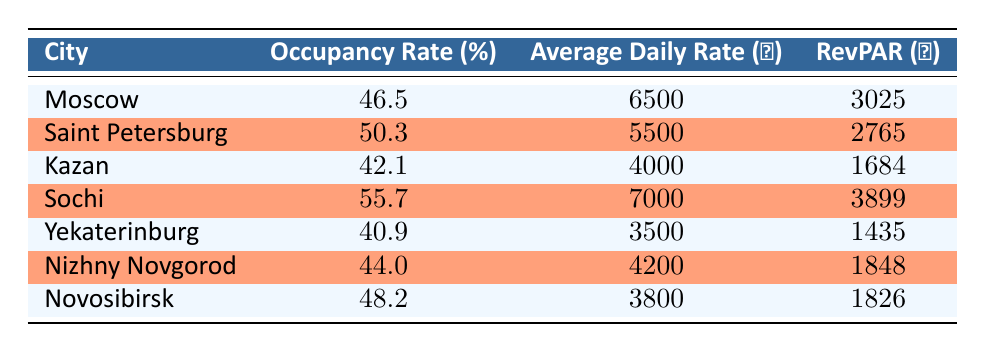What is the highest hotel occupancy rate among the listed cities? The table shows the occupancy rates for each city. Upon reviewing the numbers, Sochi has the highest rate at 55.7%.
Answer: 55.7 How does the average daily rate in Saint Petersburg compare to that in Moscow? Looking at the average daily rates, Saint Petersburg has an average daily rate of 5500, while Moscow has 6500. Comparing these, Moscow's rate is higher by 1000.
Answer: 1000 Is the revenue per available room (RevPAR) in Kazan greater than in Yekaterinburg? The values for RevPAR show Kazan at 1684 and Yekaterinburg at 1435. Since 1684 is greater than 1435, the statement is true.
Answer: Yes What is the average hotel occupancy rate for all the cities listed? To find the average occupancy rate, we sum all the rates (46.5 + 50.3 + 42.1 + 55.7 + 40.9 + 44.0 + 48.2) = 327.7. Then, we divide by the number of cities, which is 7: 327.7 / 7 = 46.7.
Answer: 46.7 Is the average daily rate for Novosibirsk less than the occupancy rate for Kazan? The average daily rate for Novosibirsk is 3800, and the occupancy rate for Kazan is 42.1%. Since the average daily rate is not less than the occupancy rate, the statement is false.
Answer: No Which city has the lowest revenue per available room (RevPAR)? By comparing the RevPAR values, we find that Yekaterinburg has the lowest value at 1435.
Answer: Yekaterinburg What is the total revenue generated per available room when combining the RevPAR of Moscow and Nizhny Novgorod? The RevPAR for Moscow is 3025 and for Nizhny Novgorod it is 1848. Adding these two values gives us a total of 3025 + 1848 = 4873.
Answer: 4873 Which city has both a higher occupancy rate and a higher average daily rate compared to Yekaterinburg? Yekaterinburg's occupancy rate is 40.9%, and its daily rate is 3500. Both Sochi (occupancy 55.7%, rate 7000) and Saint Petersburg (occupancy 50.3%, rate 5500) meet this criterion.
Answer: Sochi and Saint Petersburg 